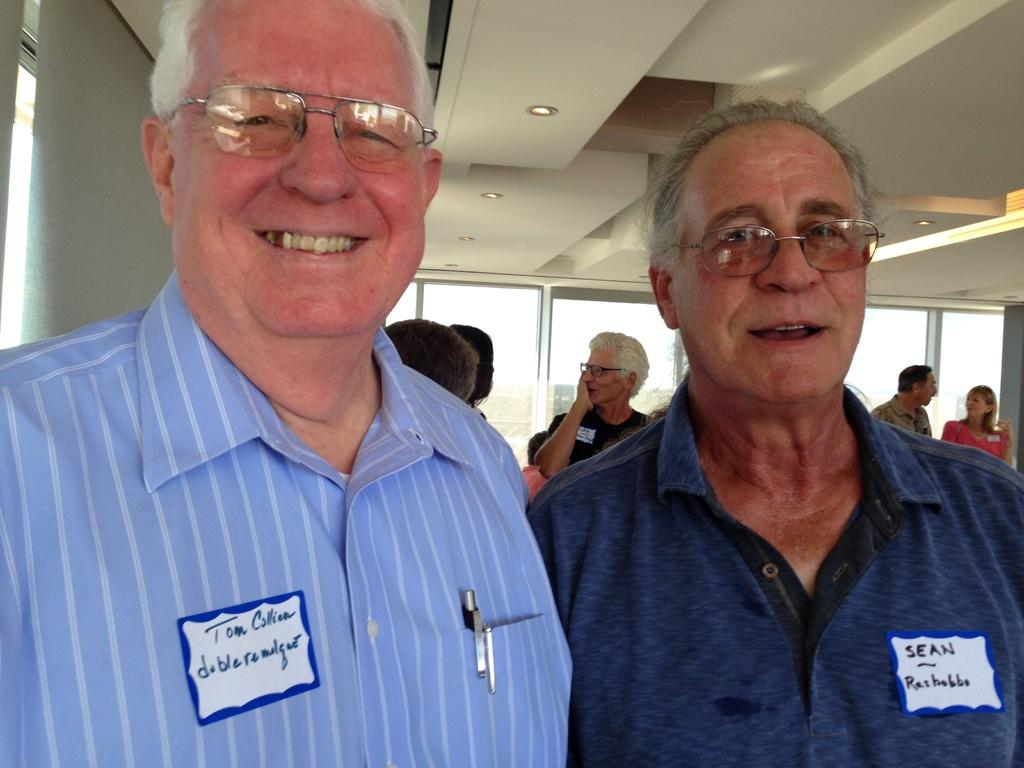Where was the image taken? The image was taken inside a room. How many people are in the image? There are persons in the image. Can you describe the two men in the front of the image? There are two men in the front of the image, and they are laughing. What type of wine is being served on the boat in the image? There is no boat or wine present in the image; it is taken inside a room with two men laughing. 